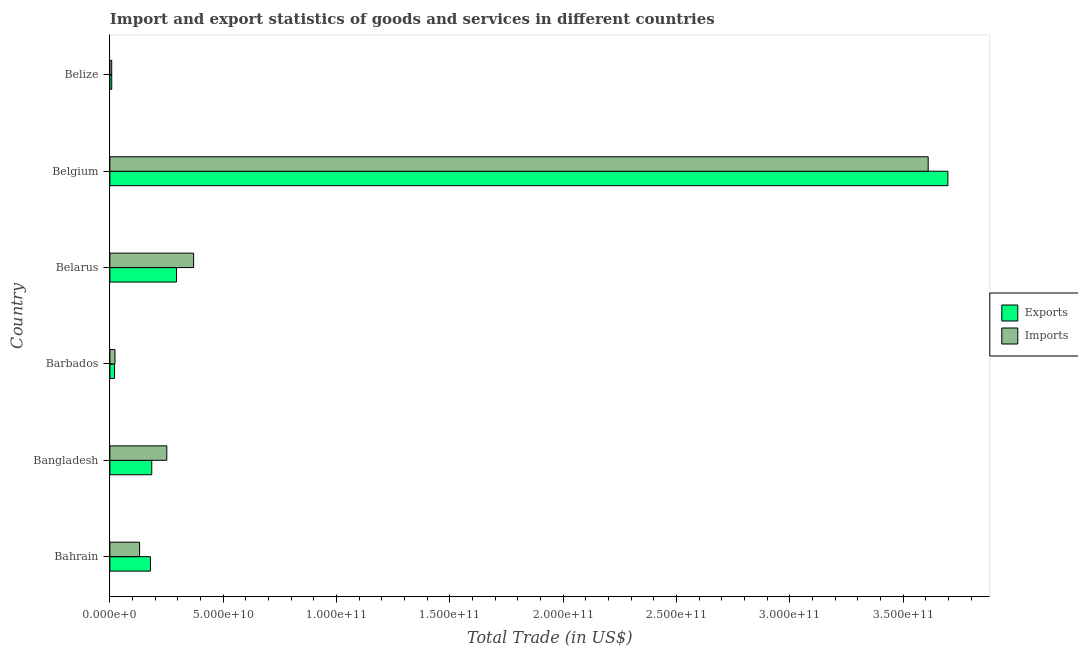How many groups of bars are there?
Offer a very short reply. 6. How many bars are there on the 1st tick from the top?
Keep it short and to the point. 2. What is the label of the 4th group of bars from the top?
Ensure brevity in your answer.  Barbados. What is the imports of goods and services in Bangladesh?
Provide a short and direct response. 2.51e+1. Across all countries, what is the maximum export of goods and services?
Provide a succinct answer. 3.70e+11. Across all countries, what is the minimum export of goods and services?
Your answer should be compact. 8.13e+08. In which country was the imports of goods and services minimum?
Keep it short and to the point. Belize. What is the total export of goods and services in the graph?
Offer a terse response. 4.38e+11. What is the difference between the imports of goods and services in Bangladesh and that in Belarus?
Your answer should be compact. -1.18e+1. What is the difference between the imports of goods and services in Bahrain and the export of goods and services in Belize?
Keep it short and to the point. 1.23e+1. What is the average export of goods and services per country?
Give a very brief answer. 7.31e+1. What is the difference between the export of goods and services and imports of goods and services in Bangladesh?
Provide a short and direct response. -6.63e+09. In how many countries, is the imports of goods and services greater than 40000000000 US$?
Your answer should be compact. 1. What is the ratio of the export of goods and services in Bahrain to that in Belize?
Offer a terse response. 21.98. Is the difference between the export of goods and services in Bahrain and Bangladesh greater than the difference between the imports of goods and services in Bahrain and Bangladesh?
Offer a very short reply. Yes. What is the difference between the highest and the second highest imports of goods and services?
Your answer should be compact. 3.24e+11. What is the difference between the highest and the lowest imports of goods and services?
Ensure brevity in your answer.  3.60e+11. In how many countries, is the imports of goods and services greater than the average imports of goods and services taken over all countries?
Your answer should be compact. 1. Is the sum of the imports of goods and services in Bahrain and Belize greater than the maximum export of goods and services across all countries?
Your response must be concise. No. What does the 1st bar from the top in Belarus represents?
Your answer should be very brief. Imports. What does the 2nd bar from the bottom in Belgium represents?
Your answer should be very brief. Imports. How many bars are there?
Give a very brief answer. 12. What is the difference between two consecutive major ticks on the X-axis?
Offer a terse response. 5.00e+1. Does the graph contain grids?
Offer a very short reply. No. What is the title of the graph?
Your answer should be very brief. Import and export statistics of goods and services in different countries. Does "Rural" appear as one of the legend labels in the graph?
Keep it short and to the point. No. What is the label or title of the X-axis?
Offer a terse response. Total Trade (in US$). What is the Total Trade (in US$) of Exports in Bahrain?
Offer a terse response. 1.79e+1. What is the Total Trade (in US$) of Imports in Bahrain?
Offer a terse response. 1.31e+1. What is the Total Trade (in US$) in Exports in Bangladesh?
Make the answer very short. 1.85e+1. What is the Total Trade (in US$) of Imports in Bangladesh?
Keep it short and to the point. 2.51e+1. What is the Total Trade (in US$) of Exports in Barbados?
Provide a succinct answer. 2.05e+09. What is the Total Trade (in US$) in Imports in Barbados?
Ensure brevity in your answer.  2.24e+09. What is the Total Trade (in US$) in Exports in Belarus?
Ensure brevity in your answer.  2.94e+1. What is the Total Trade (in US$) in Imports in Belarus?
Provide a succinct answer. 3.69e+1. What is the Total Trade (in US$) of Exports in Belgium?
Provide a short and direct response. 3.70e+11. What is the Total Trade (in US$) of Imports in Belgium?
Make the answer very short. 3.61e+11. What is the Total Trade (in US$) in Exports in Belize?
Keep it short and to the point. 8.13e+08. What is the Total Trade (in US$) of Imports in Belize?
Your response must be concise. 8.03e+08. Across all countries, what is the maximum Total Trade (in US$) of Exports?
Provide a short and direct response. 3.70e+11. Across all countries, what is the maximum Total Trade (in US$) of Imports?
Provide a short and direct response. 3.61e+11. Across all countries, what is the minimum Total Trade (in US$) in Exports?
Your answer should be very brief. 8.13e+08. Across all countries, what is the minimum Total Trade (in US$) of Imports?
Provide a succinct answer. 8.03e+08. What is the total Total Trade (in US$) in Exports in the graph?
Keep it short and to the point. 4.38e+11. What is the total Total Trade (in US$) in Imports in the graph?
Your response must be concise. 4.39e+11. What is the difference between the Total Trade (in US$) of Exports in Bahrain and that in Bangladesh?
Keep it short and to the point. -5.92e+08. What is the difference between the Total Trade (in US$) of Imports in Bahrain and that in Bangladesh?
Keep it short and to the point. -1.20e+1. What is the difference between the Total Trade (in US$) of Exports in Bahrain and that in Barbados?
Make the answer very short. 1.58e+1. What is the difference between the Total Trade (in US$) in Imports in Bahrain and that in Barbados?
Your response must be concise. 1.09e+1. What is the difference between the Total Trade (in US$) of Exports in Bahrain and that in Belarus?
Keep it short and to the point. -1.15e+1. What is the difference between the Total Trade (in US$) of Imports in Bahrain and that in Belarus?
Ensure brevity in your answer.  -2.38e+1. What is the difference between the Total Trade (in US$) in Exports in Bahrain and that in Belgium?
Make the answer very short. -3.52e+11. What is the difference between the Total Trade (in US$) of Imports in Bahrain and that in Belgium?
Give a very brief answer. -3.48e+11. What is the difference between the Total Trade (in US$) in Exports in Bahrain and that in Belize?
Provide a succinct answer. 1.71e+1. What is the difference between the Total Trade (in US$) of Imports in Bahrain and that in Belize?
Ensure brevity in your answer.  1.23e+1. What is the difference between the Total Trade (in US$) in Exports in Bangladesh and that in Barbados?
Your answer should be compact. 1.64e+1. What is the difference between the Total Trade (in US$) in Imports in Bangladesh and that in Barbados?
Provide a succinct answer. 2.29e+1. What is the difference between the Total Trade (in US$) in Exports in Bangladesh and that in Belarus?
Keep it short and to the point. -1.09e+1. What is the difference between the Total Trade (in US$) of Imports in Bangladesh and that in Belarus?
Offer a terse response. -1.18e+1. What is the difference between the Total Trade (in US$) of Exports in Bangladesh and that in Belgium?
Ensure brevity in your answer.  -3.51e+11. What is the difference between the Total Trade (in US$) in Imports in Bangladesh and that in Belgium?
Ensure brevity in your answer.  -3.36e+11. What is the difference between the Total Trade (in US$) in Exports in Bangladesh and that in Belize?
Ensure brevity in your answer.  1.77e+1. What is the difference between the Total Trade (in US$) of Imports in Bangladesh and that in Belize?
Your response must be concise. 2.43e+1. What is the difference between the Total Trade (in US$) of Exports in Barbados and that in Belarus?
Your answer should be compact. -2.73e+1. What is the difference between the Total Trade (in US$) in Imports in Barbados and that in Belarus?
Ensure brevity in your answer.  -3.47e+1. What is the difference between the Total Trade (in US$) of Exports in Barbados and that in Belgium?
Provide a succinct answer. -3.68e+11. What is the difference between the Total Trade (in US$) in Imports in Barbados and that in Belgium?
Provide a succinct answer. -3.59e+11. What is the difference between the Total Trade (in US$) in Exports in Barbados and that in Belize?
Offer a very short reply. 1.24e+09. What is the difference between the Total Trade (in US$) of Imports in Barbados and that in Belize?
Your response must be concise. 1.44e+09. What is the difference between the Total Trade (in US$) in Exports in Belarus and that in Belgium?
Offer a very short reply. -3.40e+11. What is the difference between the Total Trade (in US$) in Imports in Belarus and that in Belgium?
Make the answer very short. -3.24e+11. What is the difference between the Total Trade (in US$) in Exports in Belarus and that in Belize?
Offer a terse response. 2.86e+1. What is the difference between the Total Trade (in US$) in Imports in Belarus and that in Belize?
Your answer should be very brief. 3.61e+1. What is the difference between the Total Trade (in US$) of Exports in Belgium and that in Belize?
Your response must be concise. 3.69e+11. What is the difference between the Total Trade (in US$) in Imports in Belgium and that in Belize?
Your response must be concise. 3.60e+11. What is the difference between the Total Trade (in US$) in Exports in Bahrain and the Total Trade (in US$) in Imports in Bangladesh?
Offer a very short reply. -7.23e+09. What is the difference between the Total Trade (in US$) in Exports in Bahrain and the Total Trade (in US$) in Imports in Barbados?
Give a very brief answer. 1.56e+1. What is the difference between the Total Trade (in US$) in Exports in Bahrain and the Total Trade (in US$) in Imports in Belarus?
Give a very brief answer. -1.91e+1. What is the difference between the Total Trade (in US$) of Exports in Bahrain and the Total Trade (in US$) of Imports in Belgium?
Ensure brevity in your answer.  -3.43e+11. What is the difference between the Total Trade (in US$) of Exports in Bahrain and the Total Trade (in US$) of Imports in Belize?
Your response must be concise. 1.71e+1. What is the difference between the Total Trade (in US$) of Exports in Bangladesh and the Total Trade (in US$) of Imports in Barbados?
Your answer should be very brief. 1.62e+1. What is the difference between the Total Trade (in US$) in Exports in Bangladesh and the Total Trade (in US$) in Imports in Belarus?
Offer a very short reply. -1.85e+1. What is the difference between the Total Trade (in US$) in Exports in Bangladesh and the Total Trade (in US$) in Imports in Belgium?
Provide a short and direct response. -3.43e+11. What is the difference between the Total Trade (in US$) of Exports in Bangladesh and the Total Trade (in US$) of Imports in Belize?
Your answer should be compact. 1.77e+1. What is the difference between the Total Trade (in US$) of Exports in Barbados and the Total Trade (in US$) of Imports in Belarus?
Give a very brief answer. -3.49e+1. What is the difference between the Total Trade (in US$) in Exports in Barbados and the Total Trade (in US$) in Imports in Belgium?
Provide a short and direct response. -3.59e+11. What is the difference between the Total Trade (in US$) of Exports in Barbados and the Total Trade (in US$) of Imports in Belize?
Your response must be concise. 1.25e+09. What is the difference between the Total Trade (in US$) of Exports in Belarus and the Total Trade (in US$) of Imports in Belgium?
Give a very brief answer. -3.32e+11. What is the difference between the Total Trade (in US$) in Exports in Belarus and the Total Trade (in US$) in Imports in Belize?
Provide a succinct answer. 2.86e+1. What is the difference between the Total Trade (in US$) of Exports in Belgium and the Total Trade (in US$) of Imports in Belize?
Your response must be concise. 3.69e+11. What is the average Total Trade (in US$) of Exports per country?
Ensure brevity in your answer.  7.31e+1. What is the average Total Trade (in US$) of Imports per country?
Provide a succinct answer. 7.32e+1. What is the difference between the Total Trade (in US$) in Exports and Total Trade (in US$) in Imports in Bahrain?
Ensure brevity in your answer.  4.78e+09. What is the difference between the Total Trade (in US$) in Exports and Total Trade (in US$) in Imports in Bangladesh?
Make the answer very short. -6.63e+09. What is the difference between the Total Trade (in US$) in Exports and Total Trade (in US$) in Imports in Barbados?
Ensure brevity in your answer.  -1.86e+08. What is the difference between the Total Trade (in US$) in Exports and Total Trade (in US$) in Imports in Belarus?
Offer a very short reply. -7.54e+09. What is the difference between the Total Trade (in US$) of Exports and Total Trade (in US$) of Imports in Belgium?
Offer a very short reply. 8.69e+09. What is the difference between the Total Trade (in US$) in Exports and Total Trade (in US$) in Imports in Belize?
Your response must be concise. 1.03e+07. What is the ratio of the Total Trade (in US$) of Exports in Bahrain to that in Bangladesh?
Provide a succinct answer. 0.97. What is the ratio of the Total Trade (in US$) of Imports in Bahrain to that in Bangladesh?
Offer a very short reply. 0.52. What is the ratio of the Total Trade (in US$) in Exports in Bahrain to that in Barbados?
Keep it short and to the point. 8.7. What is the ratio of the Total Trade (in US$) of Imports in Bahrain to that in Barbados?
Ensure brevity in your answer.  5.85. What is the ratio of the Total Trade (in US$) of Exports in Bahrain to that in Belarus?
Provide a succinct answer. 0.61. What is the ratio of the Total Trade (in US$) of Imports in Bahrain to that in Belarus?
Offer a very short reply. 0.35. What is the ratio of the Total Trade (in US$) of Exports in Bahrain to that in Belgium?
Provide a short and direct response. 0.05. What is the ratio of the Total Trade (in US$) of Imports in Bahrain to that in Belgium?
Your answer should be very brief. 0.04. What is the ratio of the Total Trade (in US$) of Exports in Bahrain to that in Belize?
Ensure brevity in your answer.  21.99. What is the ratio of the Total Trade (in US$) in Imports in Bahrain to that in Belize?
Offer a terse response. 16.31. What is the ratio of the Total Trade (in US$) of Exports in Bangladesh to that in Barbados?
Your answer should be compact. 8.99. What is the ratio of the Total Trade (in US$) in Imports in Bangladesh to that in Barbados?
Provide a short and direct response. 11.21. What is the ratio of the Total Trade (in US$) in Exports in Bangladesh to that in Belarus?
Make the answer very short. 0.63. What is the ratio of the Total Trade (in US$) of Imports in Bangladesh to that in Belarus?
Make the answer very short. 0.68. What is the ratio of the Total Trade (in US$) in Exports in Bangladesh to that in Belgium?
Offer a terse response. 0.05. What is the ratio of the Total Trade (in US$) in Imports in Bangladesh to that in Belgium?
Provide a short and direct response. 0.07. What is the ratio of the Total Trade (in US$) of Exports in Bangladesh to that in Belize?
Offer a very short reply. 22.71. What is the ratio of the Total Trade (in US$) in Imports in Bangladesh to that in Belize?
Your response must be concise. 31.27. What is the ratio of the Total Trade (in US$) of Exports in Barbados to that in Belarus?
Your answer should be compact. 0.07. What is the ratio of the Total Trade (in US$) in Imports in Barbados to that in Belarus?
Provide a succinct answer. 0.06. What is the ratio of the Total Trade (in US$) in Exports in Barbados to that in Belgium?
Keep it short and to the point. 0.01. What is the ratio of the Total Trade (in US$) in Imports in Barbados to that in Belgium?
Your response must be concise. 0.01. What is the ratio of the Total Trade (in US$) in Exports in Barbados to that in Belize?
Provide a short and direct response. 2.53. What is the ratio of the Total Trade (in US$) of Imports in Barbados to that in Belize?
Provide a short and direct response. 2.79. What is the ratio of the Total Trade (in US$) of Exports in Belarus to that in Belgium?
Provide a succinct answer. 0.08. What is the ratio of the Total Trade (in US$) of Imports in Belarus to that in Belgium?
Your answer should be very brief. 0.1. What is the ratio of the Total Trade (in US$) in Exports in Belarus to that in Belize?
Provide a short and direct response. 36.15. What is the ratio of the Total Trade (in US$) in Imports in Belarus to that in Belize?
Your answer should be very brief. 46.01. What is the ratio of the Total Trade (in US$) of Exports in Belgium to that in Belize?
Make the answer very short. 454.56. What is the ratio of the Total Trade (in US$) in Imports in Belgium to that in Belize?
Provide a succinct answer. 449.59. What is the difference between the highest and the second highest Total Trade (in US$) of Exports?
Make the answer very short. 3.40e+11. What is the difference between the highest and the second highest Total Trade (in US$) of Imports?
Your answer should be compact. 3.24e+11. What is the difference between the highest and the lowest Total Trade (in US$) of Exports?
Offer a very short reply. 3.69e+11. What is the difference between the highest and the lowest Total Trade (in US$) of Imports?
Provide a succinct answer. 3.60e+11. 